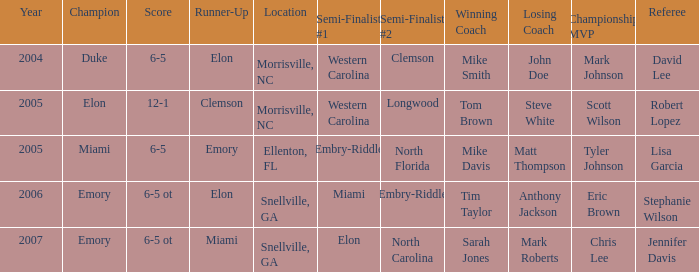Which team was the second semi finalist in 2007? North Carolina. 